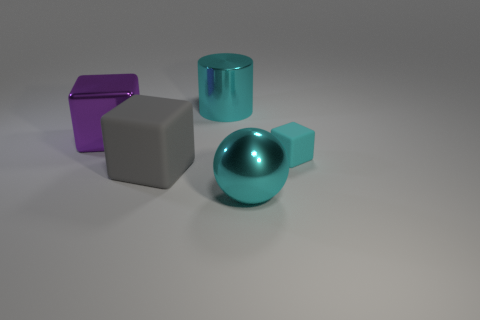What is the thing that is both on the right side of the big purple metallic block and behind the small cyan object made of?
Provide a short and direct response. Metal. Is the material of the cyan cylinder the same as the object left of the gray rubber cube?
Keep it short and to the point. Yes. Are there any other things that have the same size as the gray matte cube?
Offer a very short reply. Yes. What number of objects are either big rubber objects or blocks that are on the left side of the large cyan metallic cylinder?
Ensure brevity in your answer.  2. There is a cube that is on the right side of the big cylinder; does it have the same size as the cyan thing in front of the large matte cube?
Your answer should be very brief. No. What number of other objects are the same color as the big shiny cylinder?
Offer a terse response. 2. Is the size of the purple shiny cube the same as the rubber cube that is on the right side of the gray rubber block?
Your answer should be very brief. No. What size is the cyan shiny object that is behind the small cyan rubber thing behind the large cyan ball?
Your response must be concise. Large. There is a big metallic thing that is the same shape as the large gray rubber object; what color is it?
Keep it short and to the point. Purple. Is the cylinder the same size as the sphere?
Ensure brevity in your answer.  Yes. 